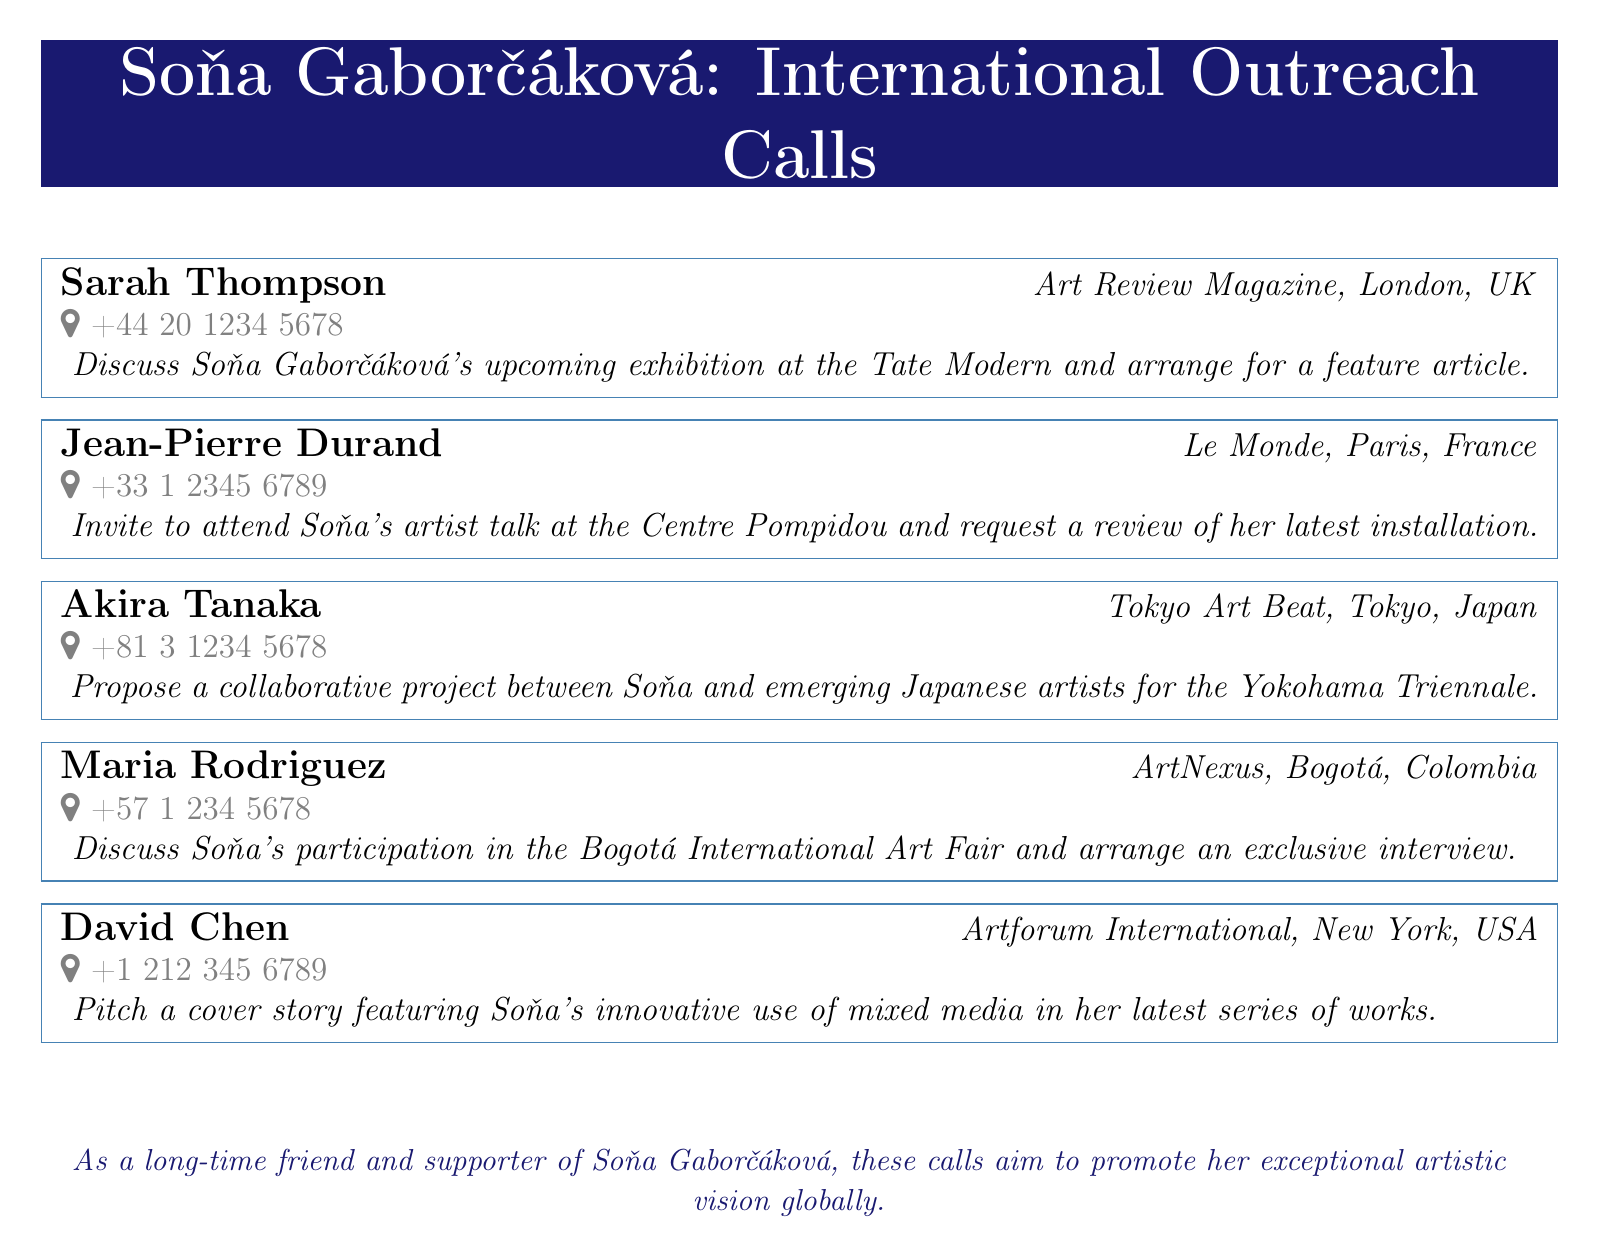what is the name of the first contact? The first contact listed in the document is Sarah Thompson.
Answer: Sarah Thompson which magazine is associated with Jean-Pierre Durand? Jean-Pierre Durand is associated with Le Monde.
Answer: Le Monde how many international calls are mentioned in the document? The document lists five international calls.
Answer: five what is the country code for the call to Tokyo? The country code for the call to Tokyo is +81.
Answer: +81 who is invited to attend an artist talk at the Centre Pompidou? Soňa Gaborčáková is invited to attend the artist talk.
Answer: Soňa Gaborčáková what event is mentioned in relation to Maria Rodriguez? The Bogotá International Art Fair is mentioned in relation to Maria Rodriguez.
Answer: Bogotá International Art Fair which publication is pitching a cover story about Soňa? Artforum International is pitching a cover story.
Answer: Artforum International which city is associated with the phone number +44 20 1234 5678? The city associated with that phone number is London.
Answer: London 